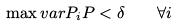<formula> <loc_0><loc_0><loc_500><loc_500>\max v a r { P _ { i } } { P } < \delta \quad \forall i</formula> 